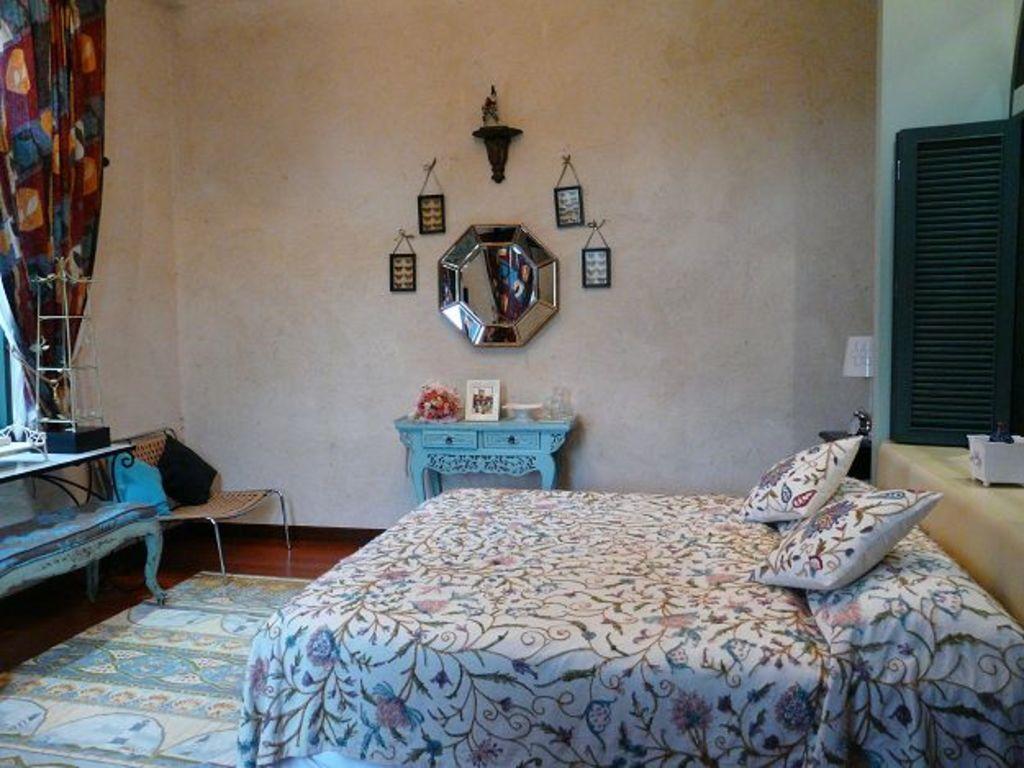How would you summarize this image in a sentence or two? This looks like a bedroom. This is a bed covered with blanket. These are the pillows. I can see a small chair with cushions on it. This is a table with a flower bouquet,photo frame and some object. This is a mirror attached to the wall. This is a curtain hanging. This is a carpet on the floor. 